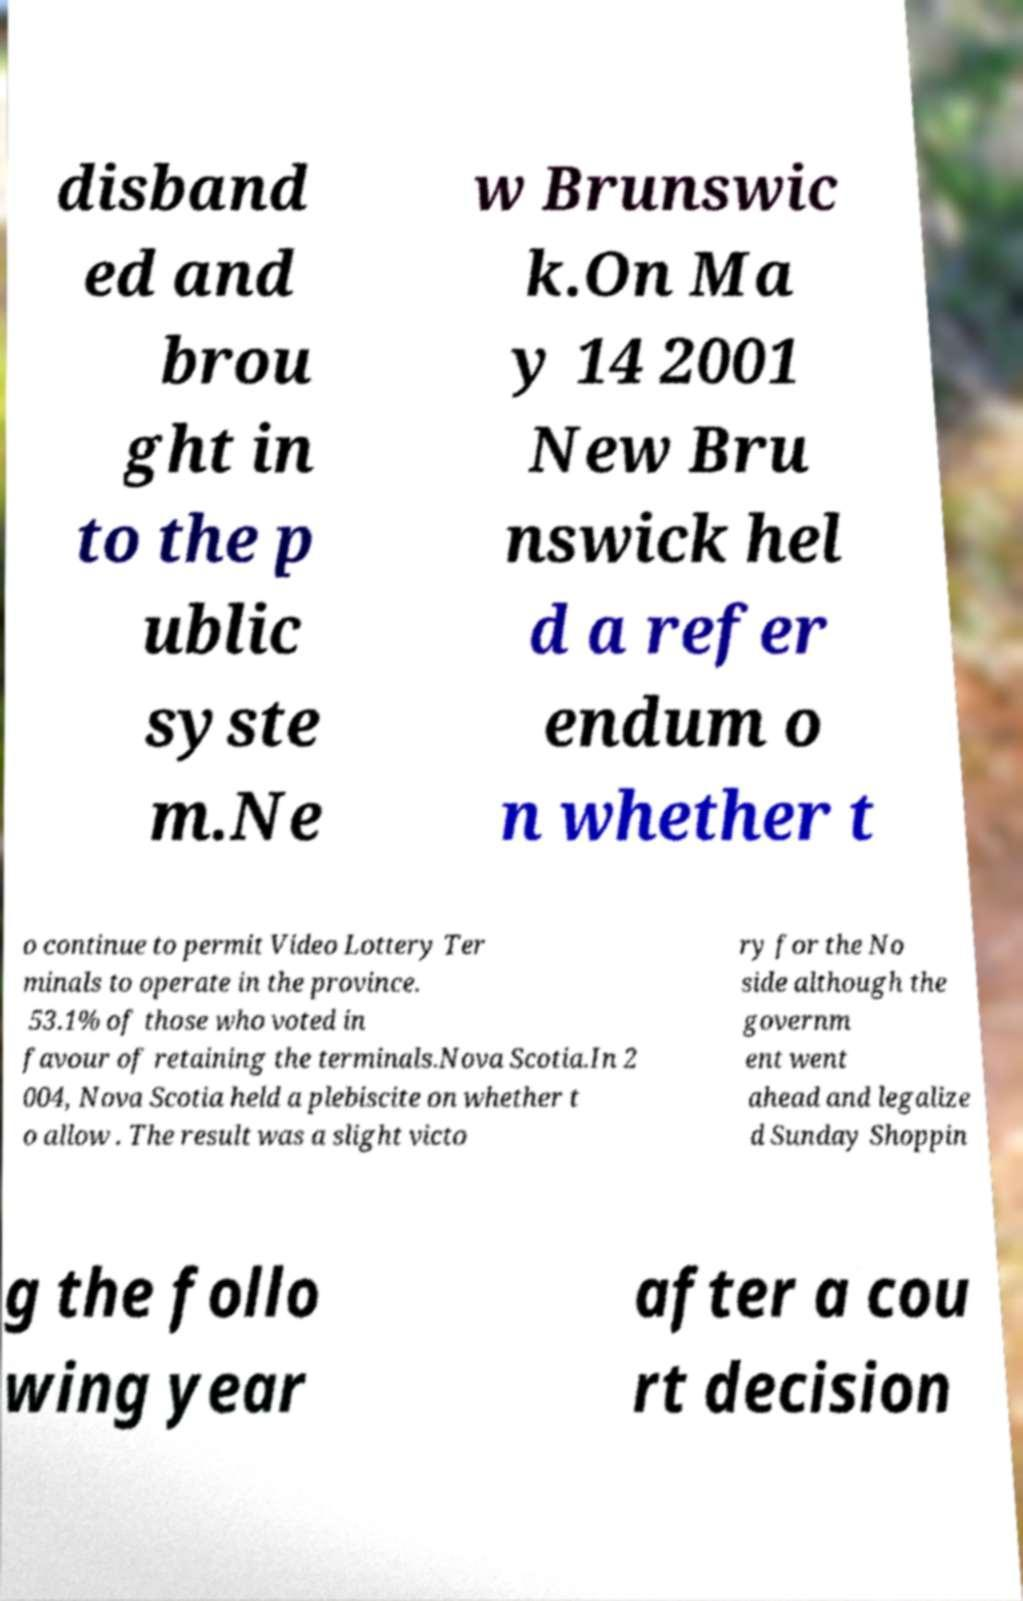Please read and relay the text visible in this image. What does it say? disband ed and brou ght in to the p ublic syste m.Ne w Brunswic k.On Ma y 14 2001 New Bru nswick hel d a refer endum o n whether t o continue to permit Video Lottery Ter minals to operate in the province. 53.1% of those who voted in favour of retaining the terminals.Nova Scotia.In 2 004, Nova Scotia held a plebiscite on whether t o allow . The result was a slight victo ry for the No side although the governm ent went ahead and legalize d Sunday Shoppin g the follo wing year after a cou rt decision 